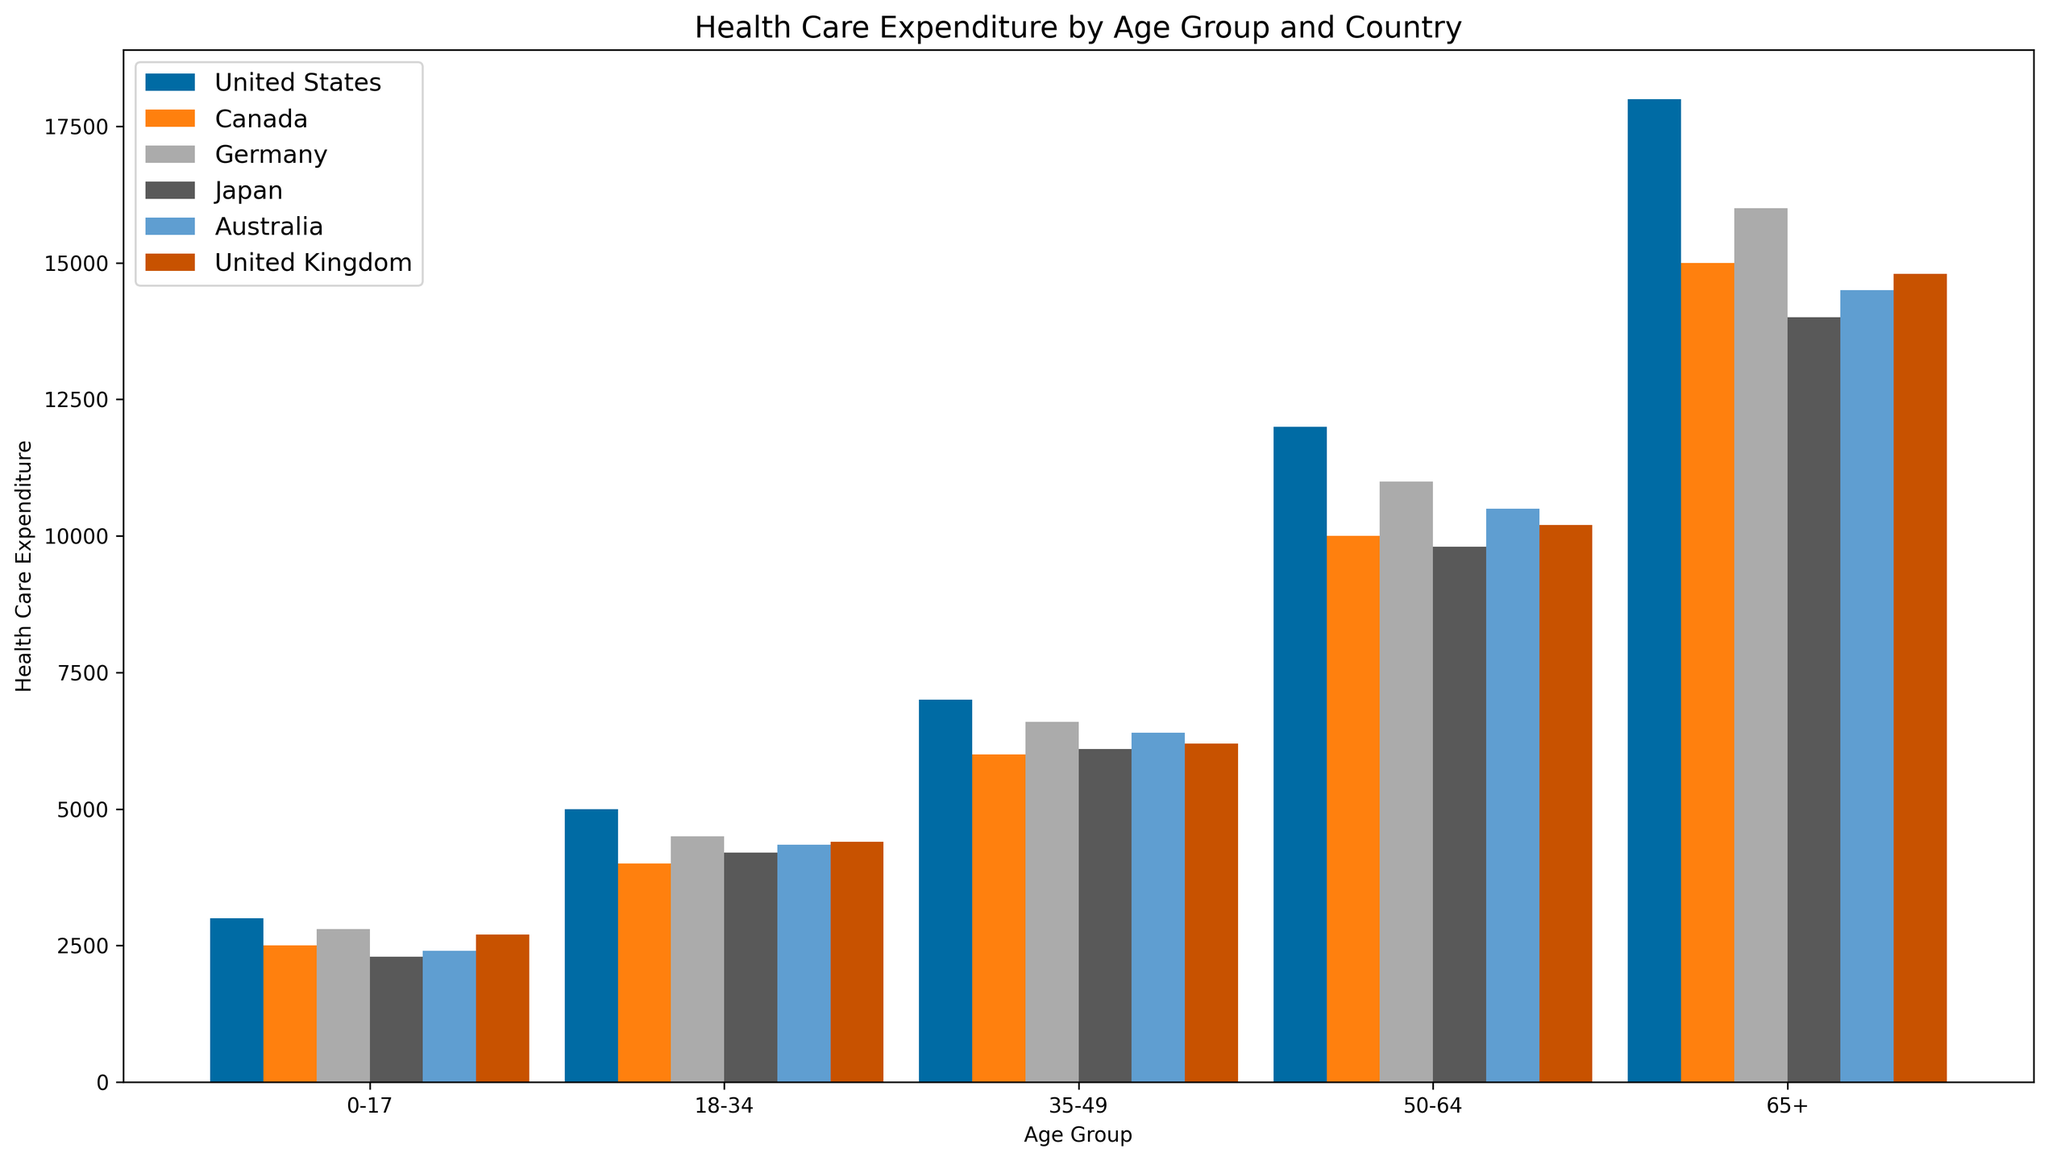What is the highest Health Care Expenditure in the 65+ age group? The tallest bar in the '65+' age group represents the highest Health Care Expenditure among that age group. By observing the figure, the highest bar in this age category belongs to the United States.
Answer: 18000 Which country has the lowest Health Care Expenditure for the 0-17 age group? To find the country with the lowest expenditure for the 0-17 age group, look for the shortest bar in this category. Comparing the bars, Japan has the lowest height in this age group.
Answer: Japan What is the total Health Care Expenditure for ages 35-49 in the United States and Canada combined? To determine the total expenditure, add the values of the '35-49' age group for both the United States and Canada. The expenditures are 7000 and 6000 respectively for these countries. Therefore, 7000 + 6000 = 13000.
Answer: 13000 Between Canada and Germany, which country has the higher Health Care Expenditure for the 50-64 age group, and by how much? To determine which country has higher expenditure and by how much, compare the heights of the bars. Canada has an expenditure of 10000, while Germany has 11000 for the 50-64 age group. The difference is 11000 - 10000 = 1000. Therefore, Germany spends 1000 more than Canada.
Answer: Germany, 1000 Which age group has the highest variability in Health Care Expenditure across all countries? By visually comparing the range of bar heights within each age group, we observe that the 65+ age group exhibits the greatest variability. This is demonstrated by the wide range between the highest and lowest expenditure values in this age group.
Answer: 65+ What is the average Health Care Expenditure for all countries in the 18-34 age group? To find the average, sum the expenditures of all countries in the 18-34 age group and divide by the number of countries. The expenditures are 5000, 4000, 4500, 4200, 4350, and 4400 respectively. Sum these values: 5000 + 4000 + 4500 + 4200 + 4350 + 4400 = 26450. The average is 26450 / 6 = 4408.33.
Answer: 4408.33 Which country has the most consistent (least variable) Health Care Expenditure across all age groups? Consistency across age groups can be visually assessed by observing the bars' relative heights for each country. Australia shows relatively uniform bar heights compared to other countries, indicating consistent expenditure across age groups.
Answer: Australia 